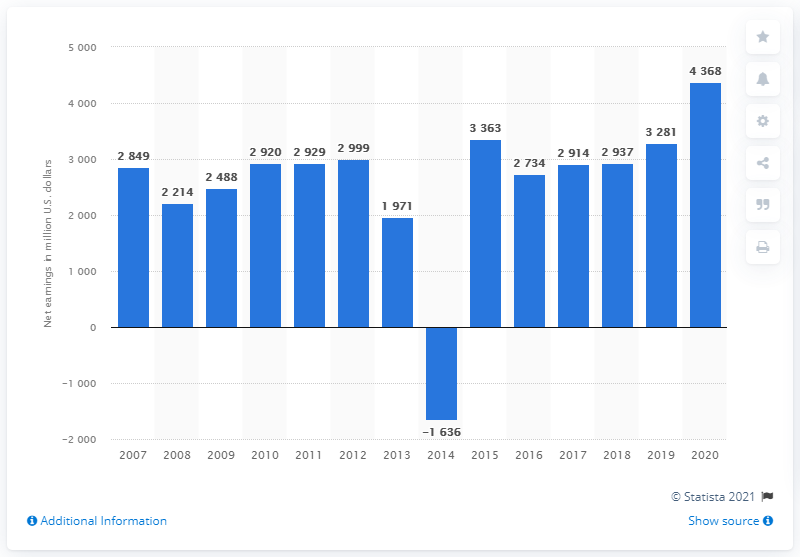Specify some key components in this picture. The net earnings of Target in the United States in 2020 were 4,368. 